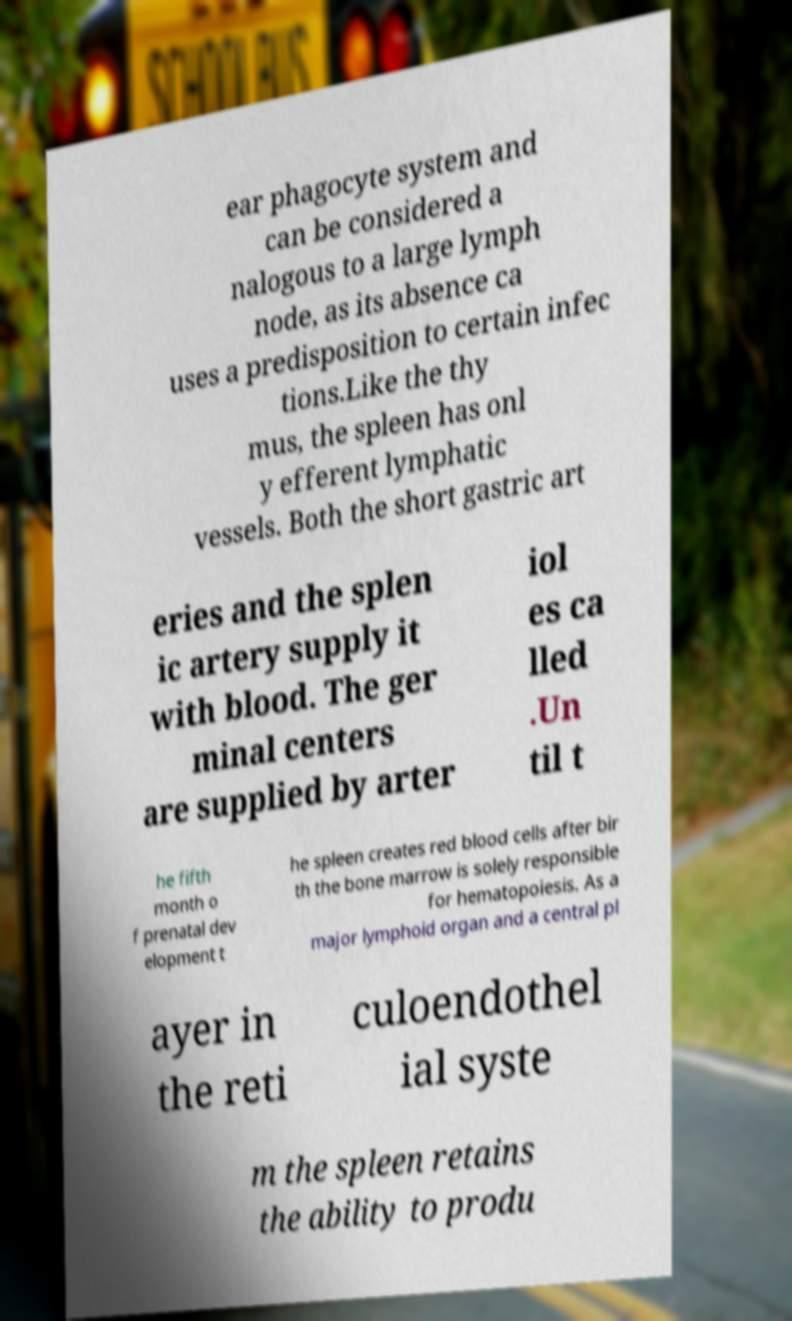For documentation purposes, I need the text within this image transcribed. Could you provide that? ear phagocyte system and can be considered a nalogous to a large lymph node, as its absence ca uses a predisposition to certain infec tions.Like the thy mus, the spleen has onl y efferent lymphatic vessels. Both the short gastric art eries and the splen ic artery supply it with blood. The ger minal centers are supplied by arter iol es ca lled .Un til t he fifth month o f prenatal dev elopment t he spleen creates red blood cells after bir th the bone marrow is solely responsible for hematopoiesis. As a major lymphoid organ and a central pl ayer in the reti culoendothel ial syste m the spleen retains the ability to produ 